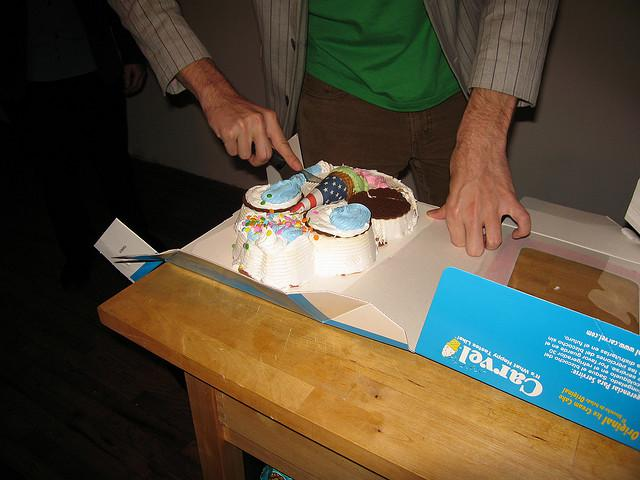What cool treat can be found inside this cake? ice cream 